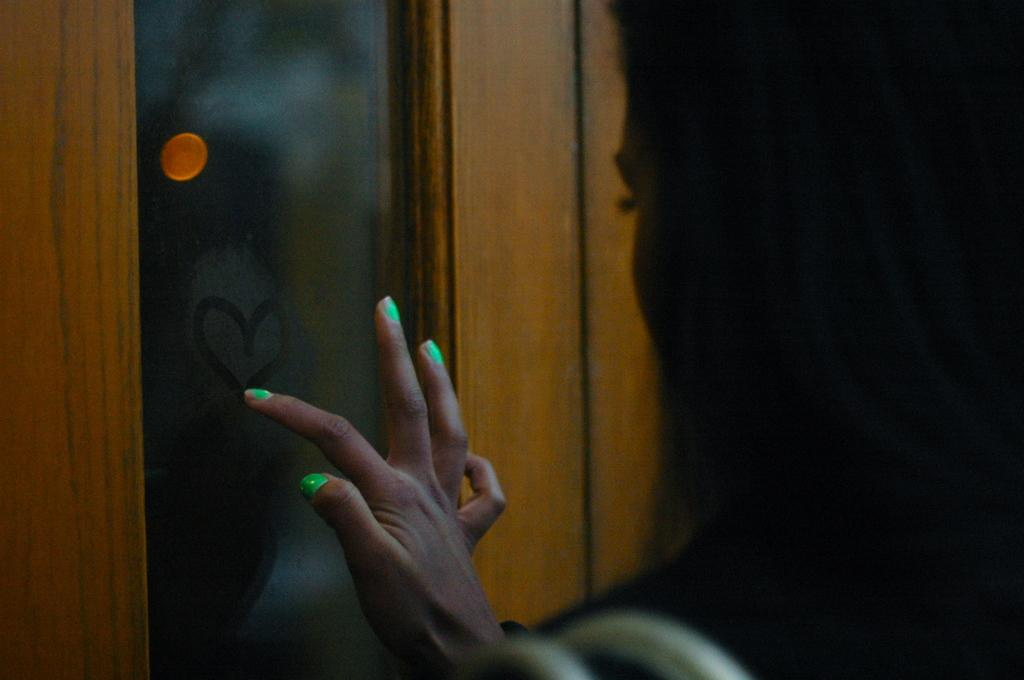Who is the main subject in the image? There is a woman in the image. What direction is the woman facing? The woman is facing towards the left. What is the woman doing in the image? The woman is drawing a heart shape on a glass. Can you describe the condition of the glass? The glass has mist on it and the word "beside" written on it. Who is the friend standing beside the woman in the image? There is no friend present in the image; the woman is alone. What type of ornament is hanging on the frame in the image? There is no frame or ornament present in the image. 